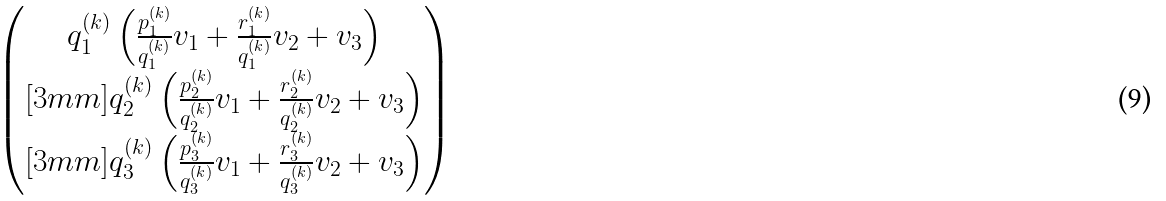<formula> <loc_0><loc_0><loc_500><loc_500>\begin{pmatrix} q _ { 1 } ^ { ( k ) } \left ( \frac { p _ { 1 } ^ { ( k ) } } { q _ { 1 } ^ { ( k ) } } v _ { 1 } + \frac { r _ { 1 } ^ { ( k ) } } { q _ { 1 } ^ { ( k ) } } v _ { 2 } + v _ { 3 } \right ) \\ [ 3 m m ] q _ { 2 } ^ { ( k ) } \left ( \frac { p _ { 2 } ^ { ( k ) } } { q _ { 2 } ^ { ( k ) } } v _ { 1 } + \frac { r _ { 2 } ^ { ( k ) } } { q _ { 2 } ^ { ( k ) } } v _ { 2 } + v _ { 3 } \right ) \\ [ 3 m m ] q _ { 3 } ^ { ( k ) } \left ( \frac { p _ { 3 } ^ { ( k ) } } { q _ { 3 } ^ { ( k ) } } v _ { 1 } + \frac { r _ { 3 } ^ { ( k ) } } { q _ { 3 } ^ { ( k ) } } v _ { 2 } + v _ { 3 } \right ) \end{pmatrix}</formula> 